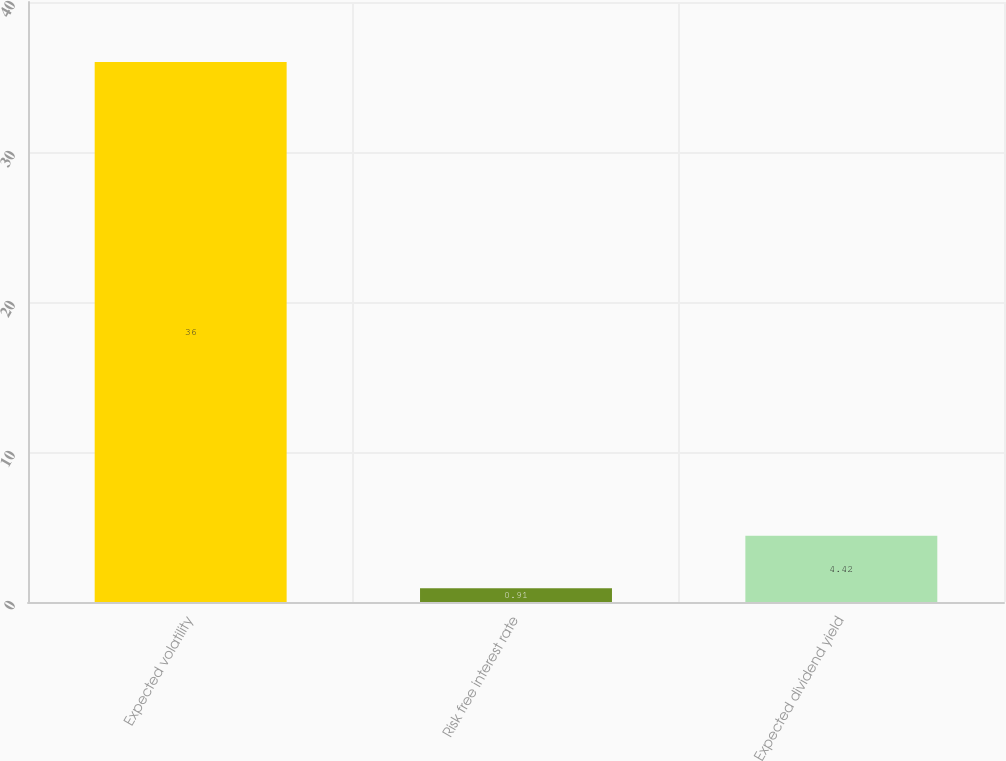Convert chart to OTSL. <chart><loc_0><loc_0><loc_500><loc_500><bar_chart><fcel>Expected volatility<fcel>Risk free interest rate<fcel>Expected dividend yield<nl><fcel>36<fcel>0.91<fcel>4.42<nl></chart> 